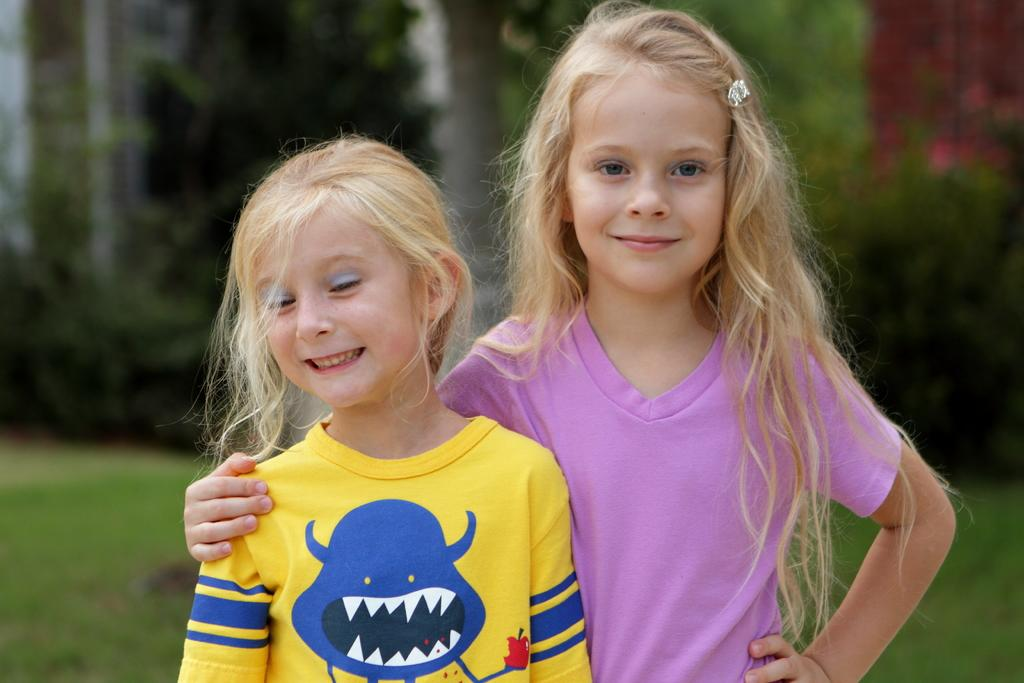How many kids are present in the image? There are two kids in the image. What are the kids doing in the image? The kids are standing and smiling. What can be seen in the background of the image? There are trees in the image. How would you describe the background of the image? The background is blurred. What type of linen is being used to dry the kids after a trip in the image? There is no trip or linen present in the image. The kids are standing and smiling, and there are trees in the background. 